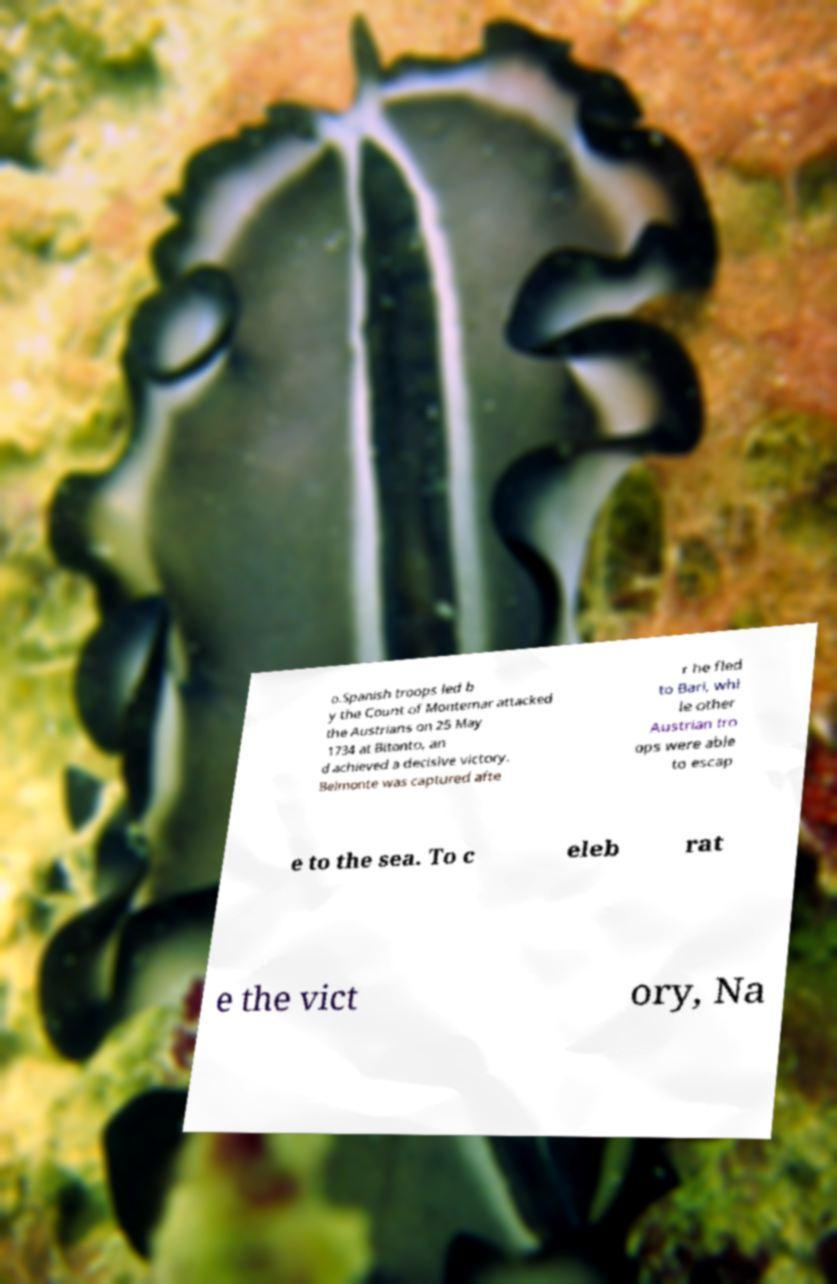Could you extract and type out the text from this image? o.Spanish troops led b y the Count of Montemar attacked the Austrians on 25 May 1734 at Bitonto, an d achieved a decisive victory. Belmonte was captured afte r he fled to Bari, whi le other Austrian tro ops were able to escap e to the sea. To c eleb rat e the vict ory, Na 